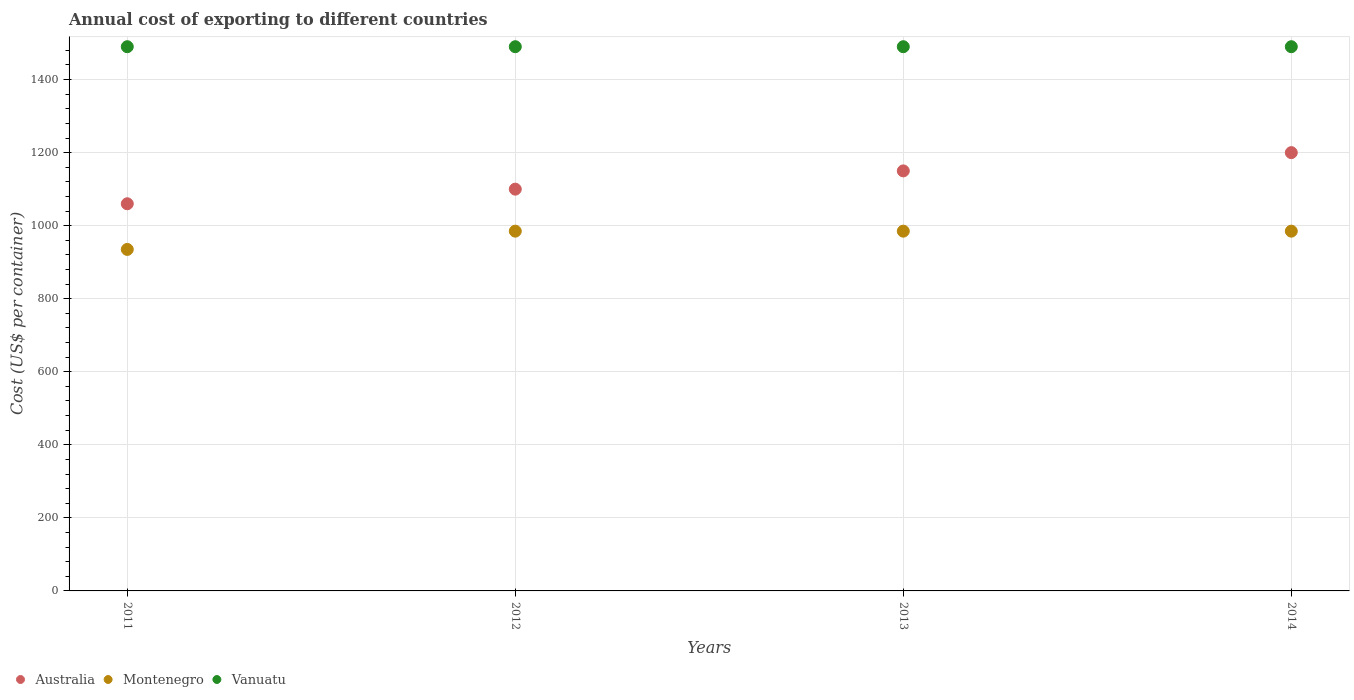How many different coloured dotlines are there?
Give a very brief answer. 3. Is the number of dotlines equal to the number of legend labels?
Ensure brevity in your answer.  Yes. What is the total annual cost of exporting in Montenegro in 2013?
Provide a succinct answer. 985. Across all years, what is the maximum total annual cost of exporting in Montenegro?
Offer a very short reply. 985. Across all years, what is the minimum total annual cost of exporting in Vanuatu?
Provide a short and direct response. 1490. What is the total total annual cost of exporting in Vanuatu in the graph?
Offer a terse response. 5960. What is the difference between the total annual cost of exporting in Montenegro in 2011 and that in 2014?
Your answer should be very brief. -50. What is the difference between the total annual cost of exporting in Montenegro in 2013 and the total annual cost of exporting in Vanuatu in 2012?
Provide a succinct answer. -505. What is the average total annual cost of exporting in Montenegro per year?
Offer a very short reply. 972.5. In the year 2012, what is the difference between the total annual cost of exporting in Vanuatu and total annual cost of exporting in Australia?
Give a very brief answer. 390. In how many years, is the total annual cost of exporting in Montenegro greater than 720 US$?
Provide a succinct answer. 4. What is the difference between the highest and the lowest total annual cost of exporting in Australia?
Make the answer very short. 140. Is it the case that in every year, the sum of the total annual cost of exporting in Montenegro and total annual cost of exporting in Vanuatu  is greater than the total annual cost of exporting in Australia?
Provide a short and direct response. Yes. Is the total annual cost of exporting in Vanuatu strictly greater than the total annual cost of exporting in Australia over the years?
Provide a succinct answer. Yes. How many dotlines are there?
Make the answer very short. 3. What is the difference between two consecutive major ticks on the Y-axis?
Offer a terse response. 200. Does the graph contain any zero values?
Your answer should be compact. No. Does the graph contain grids?
Keep it short and to the point. Yes. What is the title of the graph?
Ensure brevity in your answer.  Annual cost of exporting to different countries. What is the label or title of the Y-axis?
Ensure brevity in your answer.  Cost (US$ per container). What is the Cost (US$ per container) in Australia in 2011?
Provide a succinct answer. 1060. What is the Cost (US$ per container) in Montenegro in 2011?
Ensure brevity in your answer.  935. What is the Cost (US$ per container) in Vanuatu in 2011?
Ensure brevity in your answer.  1490. What is the Cost (US$ per container) in Australia in 2012?
Your response must be concise. 1100. What is the Cost (US$ per container) in Montenegro in 2012?
Give a very brief answer. 985. What is the Cost (US$ per container) of Vanuatu in 2012?
Your response must be concise. 1490. What is the Cost (US$ per container) of Australia in 2013?
Your answer should be compact. 1150. What is the Cost (US$ per container) of Montenegro in 2013?
Make the answer very short. 985. What is the Cost (US$ per container) of Vanuatu in 2013?
Your response must be concise. 1490. What is the Cost (US$ per container) of Australia in 2014?
Keep it short and to the point. 1200. What is the Cost (US$ per container) of Montenegro in 2014?
Provide a succinct answer. 985. What is the Cost (US$ per container) in Vanuatu in 2014?
Give a very brief answer. 1490. Across all years, what is the maximum Cost (US$ per container) of Australia?
Ensure brevity in your answer.  1200. Across all years, what is the maximum Cost (US$ per container) of Montenegro?
Your answer should be very brief. 985. Across all years, what is the maximum Cost (US$ per container) of Vanuatu?
Provide a short and direct response. 1490. Across all years, what is the minimum Cost (US$ per container) in Australia?
Offer a very short reply. 1060. Across all years, what is the minimum Cost (US$ per container) of Montenegro?
Your answer should be compact. 935. Across all years, what is the minimum Cost (US$ per container) of Vanuatu?
Offer a terse response. 1490. What is the total Cost (US$ per container) in Australia in the graph?
Your response must be concise. 4510. What is the total Cost (US$ per container) of Montenegro in the graph?
Your answer should be compact. 3890. What is the total Cost (US$ per container) of Vanuatu in the graph?
Provide a succinct answer. 5960. What is the difference between the Cost (US$ per container) in Australia in 2011 and that in 2013?
Your answer should be compact. -90. What is the difference between the Cost (US$ per container) in Montenegro in 2011 and that in 2013?
Your response must be concise. -50. What is the difference between the Cost (US$ per container) in Vanuatu in 2011 and that in 2013?
Give a very brief answer. 0. What is the difference between the Cost (US$ per container) of Australia in 2011 and that in 2014?
Your answer should be compact. -140. What is the difference between the Cost (US$ per container) in Vanuatu in 2011 and that in 2014?
Your answer should be very brief. 0. What is the difference between the Cost (US$ per container) of Vanuatu in 2012 and that in 2013?
Make the answer very short. 0. What is the difference between the Cost (US$ per container) in Australia in 2012 and that in 2014?
Your answer should be compact. -100. What is the difference between the Cost (US$ per container) of Montenegro in 2012 and that in 2014?
Your answer should be very brief. 0. What is the difference between the Cost (US$ per container) in Montenegro in 2013 and that in 2014?
Give a very brief answer. 0. What is the difference between the Cost (US$ per container) of Australia in 2011 and the Cost (US$ per container) of Vanuatu in 2012?
Offer a terse response. -430. What is the difference between the Cost (US$ per container) in Montenegro in 2011 and the Cost (US$ per container) in Vanuatu in 2012?
Give a very brief answer. -555. What is the difference between the Cost (US$ per container) in Australia in 2011 and the Cost (US$ per container) in Montenegro in 2013?
Your response must be concise. 75. What is the difference between the Cost (US$ per container) in Australia in 2011 and the Cost (US$ per container) in Vanuatu in 2013?
Offer a very short reply. -430. What is the difference between the Cost (US$ per container) in Montenegro in 2011 and the Cost (US$ per container) in Vanuatu in 2013?
Offer a very short reply. -555. What is the difference between the Cost (US$ per container) of Australia in 2011 and the Cost (US$ per container) of Montenegro in 2014?
Give a very brief answer. 75. What is the difference between the Cost (US$ per container) of Australia in 2011 and the Cost (US$ per container) of Vanuatu in 2014?
Your response must be concise. -430. What is the difference between the Cost (US$ per container) in Montenegro in 2011 and the Cost (US$ per container) in Vanuatu in 2014?
Ensure brevity in your answer.  -555. What is the difference between the Cost (US$ per container) of Australia in 2012 and the Cost (US$ per container) of Montenegro in 2013?
Give a very brief answer. 115. What is the difference between the Cost (US$ per container) in Australia in 2012 and the Cost (US$ per container) in Vanuatu in 2013?
Keep it short and to the point. -390. What is the difference between the Cost (US$ per container) of Montenegro in 2012 and the Cost (US$ per container) of Vanuatu in 2013?
Your answer should be compact. -505. What is the difference between the Cost (US$ per container) of Australia in 2012 and the Cost (US$ per container) of Montenegro in 2014?
Your answer should be compact. 115. What is the difference between the Cost (US$ per container) of Australia in 2012 and the Cost (US$ per container) of Vanuatu in 2014?
Give a very brief answer. -390. What is the difference between the Cost (US$ per container) in Montenegro in 2012 and the Cost (US$ per container) in Vanuatu in 2014?
Offer a terse response. -505. What is the difference between the Cost (US$ per container) of Australia in 2013 and the Cost (US$ per container) of Montenegro in 2014?
Offer a terse response. 165. What is the difference between the Cost (US$ per container) of Australia in 2013 and the Cost (US$ per container) of Vanuatu in 2014?
Provide a succinct answer. -340. What is the difference between the Cost (US$ per container) of Montenegro in 2013 and the Cost (US$ per container) of Vanuatu in 2014?
Ensure brevity in your answer.  -505. What is the average Cost (US$ per container) in Australia per year?
Offer a very short reply. 1127.5. What is the average Cost (US$ per container) of Montenegro per year?
Your response must be concise. 972.5. What is the average Cost (US$ per container) of Vanuatu per year?
Offer a very short reply. 1490. In the year 2011, what is the difference between the Cost (US$ per container) of Australia and Cost (US$ per container) of Montenegro?
Your answer should be very brief. 125. In the year 2011, what is the difference between the Cost (US$ per container) of Australia and Cost (US$ per container) of Vanuatu?
Give a very brief answer. -430. In the year 2011, what is the difference between the Cost (US$ per container) in Montenegro and Cost (US$ per container) in Vanuatu?
Provide a short and direct response. -555. In the year 2012, what is the difference between the Cost (US$ per container) of Australia and Cost (US$ per container) of Montenegro?
Your answer should be compact. 115. In the year 2012, what is the difference between the Cost (US$ per container) in Australia and Cost (US$ per container) in Vanuatu?
Make the answer very short. -390. In the year 2012, what is the difference between the Cost (US$ per container) in Montenegro and Cost (US$ per container) in Vanuatu?
Provide a succinct answer. -505. In the year 2013, what is the difference between the Cost (US$ per container) in Australia and Cost (US$ per container) in Montenegro?
Make the answer very short. 165. In the year 2013, what is the difference between the Cost (US$ per container) of Australia and Cost (US$ per container) of Vanuatu?
Your answer should be very brief. -340. In the year 2013, what is the difference between the Cost (US$ per container) of Montenegro and Cost (US$ per container) of Vanuatu?
Keep it short and to the point. -505. In the year 2014, what is the difference between the Cost (US$ per container) in Australia and Cost (US$ per container) in Montenegro?
Keep it short and to the point. 215. In the year 2014, what is the difference between the Cost (US$ per container) of Australia and Cost (US$ per container) of Vanuatu?
Offer a terse response. -290. In the year 2014, what is the difference between the Cost (US$ per container) of Montenegro and Cost (US$ per container) of Vanuatu?
Your response must be concise. -505. What is the ratio of the Cost (US$ per container) in Australia in 2011 to that in 2012?
Give a very brief answer. 0.96. What is the ratio of the Cost (US$ per container) of Montenegro in 2011 to that in 2012?
Offer a very short reply. 0.95. What is the ratio of the Cost (US$ per container) of Vanuatu in 2011 to that in 2012?
Offer a terse response. 1. What is the ratio of the Cost (US$ per container) of Australia in 2011 to that in 2013?
Offer a terse response. 0.92. What is the ratio of the Cost (US$ per container) in Montenegro in 2011 to that in 2013?
Your response must be concise. 0.95. What is the ratio of the Cost (US$ per container) of Vanuatu in 2011 to that in 2013?
Provide a short and direct response. 1. What is the ratio of the Cost (US$ per container) of Australia in 2011 to that in 2014?
Your response must be concise. 0.88. What is the ratio of the Cost (US$ per container) of Montenegro in 2011 to that in 2014?
Your answer should be compact. 0.95. What is the ratio of the Cost (US$ per container) of Australia in 2012 to that in 2013?
Offer a very short reply. 0.96. What is the ratio of the Cost (US$ per container) in Vanuatu in 2012 to that in 2013?
Provide a short and direct response. 1. What is the ratio of the Cost (US$ per container) of Vanuatu in 2013 to that in 2014?
Ensure brevity in your answer.  1. What is the difference between the highest and the second highest Cost (US$ per container) of Montenegro?
Make the answer very short. 0. What is the difference between the highest and the second highest Cost (US$ per container) of Vanuatu?
Make the answer very short. 0. What is the difference between the highest and the lowest Cost (US$ per container) in Australia?
Offer a very short reply. 140. What is the difference between the highest and the lowest Cost (US$ per container) of Montenegro?
Ensure brevity in your answer.  50. What is the difference between the highest and the lowest Cost (US$ per container) of Vanuatu?
Offer a very short reply. 0. 